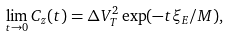Convert formula to latex. <formula><loc_0><loc_0><loc_500><loc_500>\lim _ { t \rightarrow 0 } C _ { z } ( t ) = \Delta V _ { T } ^ { 2 } \exp ( - t \xi _ { E } / M ) ,</formula> 